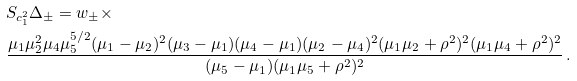Convert formula to latex. <formula><loc_0><loc_0><loc_500><loc_500>& S _ { c _ { 1 } ^ { 2 } } \Delta _ { \pm } = w _ { \pm } \times \\ & \frac { \mu _ { 1 } \mu _ { 2 } ^ { 2 } \mu _ { 4 } \mu _ { 5 } ^ { 5 / 2 } ( \mu _ { 1 } - \mu _ { 2 } ) ^ { 2 } ( \mu _ { 3 } - \mu _ { 1 } ) ( \mu _ { 4 } - \mu _ { 1 } ) ( \mu _ { 2 } - \mu _ { 4 } ) ^ { 2 } ( \mu _ { 1 } \mu _ { 2 } + \rho ^ { 2 } ) ^ { 2 } ( \mu _ { 1 } \mu _ { 4 } + \rho ^ { 2 } ) ^ { 2 } } { ( \mu _ { 5 } - \mu _ { 1 } ) ( \mu _ { 1 } \mu _ { 5 } + \rho ^ { 2 } ) ^ { 2 } } \, .</formula> 